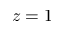Convert formula to latex. <formula><loc_0><loc_0><loc_500><loc_500>z = 1</formula> 